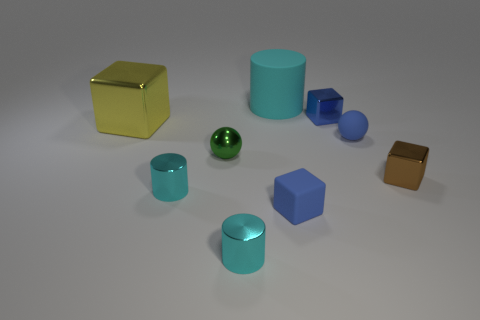Do the cyan cylinder that is behind the tiny brown block and the tiny brown object have the same material?
Keep it short and to the point. No. What is the shape of the small cyan thing to the right of the small metal sphere?
Your answer should be very brief. Cylinder. There is another sphere that is the same size as the green metal ball; what is its material?
Your response must be concise. Rubber. What number of things are either small blue blocks behind the tiny brown block or small metal things in front of the tiny brown shiny block?
Your response must be concise. 3. What size is the blue object that is made of the same material as the large yellow thing?
Give a very brief answer. Small. What number of matte things are blue cylinders or big objects?
Your answer should be compact. 1. What is the size of the blue rubber cube?
Give a very brief answer. Small. Does the matte cube have the same size as the rubber cylinder?
Give a very brief answer. No. What is the material of the small ball to the right of the large cylinder?
Ensure brevity in your answer.  Rubber. There is a small blue object that is the same shape as the green object; what material is it?
Give a very brief answer. Rubber. 